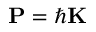Convert formula to latex. <formula><loc_0><loc_0><loc_500><loc_500>P = \hbar { K }</formula> 